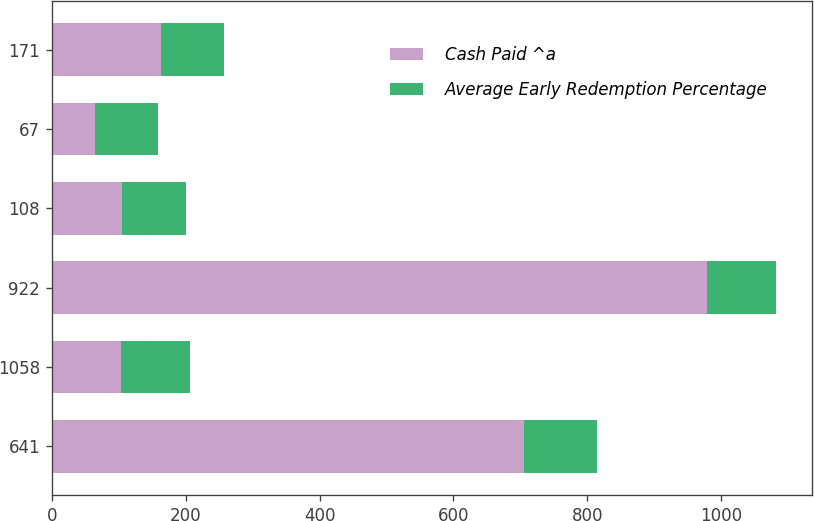Convert chart. <chart><loc_0><loc_0><loc_500><loc_500><stacked_bar_chart><ecel><fcel>641<fcel>1058<fcel>922<fcel>108<fcel>67<fcel>171<nl><fcel>Cash Paid ^a<fcel>706<fcel>104<fcel>978<fcel>105<fcel>64<fcel>163<nl><fcel>Average Early Redemption Percentage<fcel>107.89<fcel>103.12<fcel>104<fcel>94.73<fcel>94.13<fcel>94.52<nl></chart> 